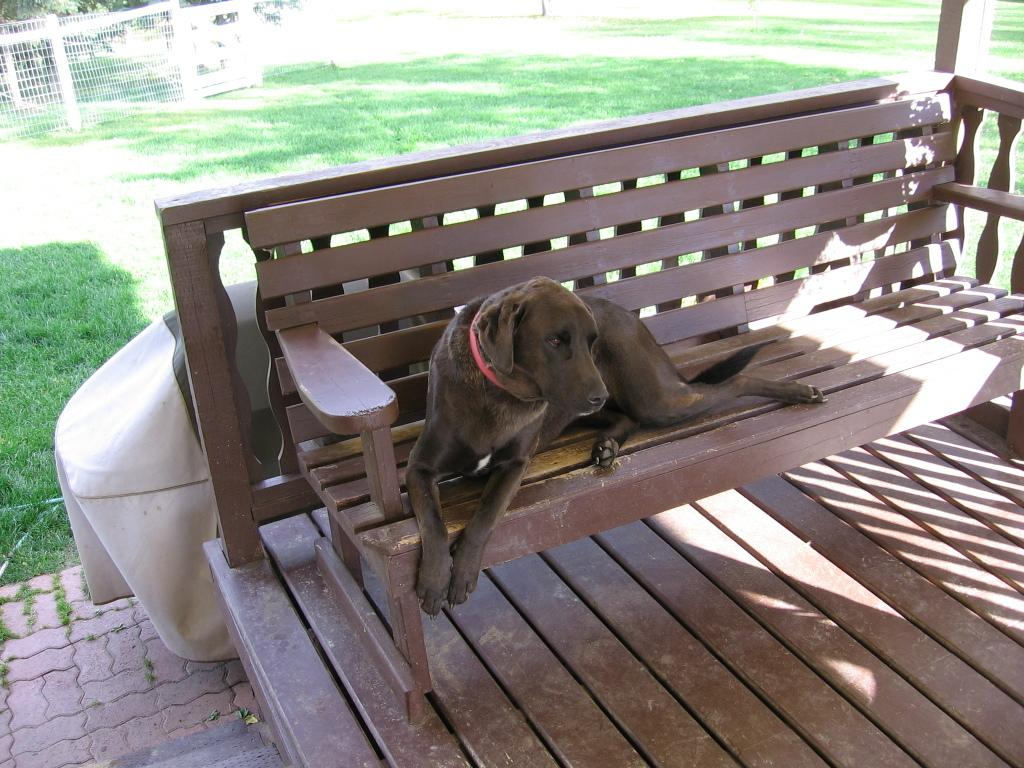What animal can be seen in the image? There is a dog in the image. Where is the dog located? The dog is on a bench. What can be seen in the background of the image? There is a fence and trees in the background of the image. What object is on the ground in the image? There is an object on the ground in the image, but we cannot determine its exact nature from the provided facts. What type of bubble is the dog playing with in the image? There is no bubble present in the image; the dog is on a bench. What mark does the dog leave on the bench? The image does not show any marks left by the dog on the bench. 